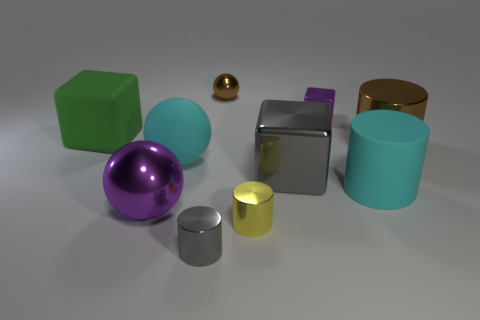There is a big brown shiny thing; how many big shiny objects are in front of it?
Your response must be concise. 2. How many balls are there?
Your answer should be compact. 3. Do the green matte block and the gray metallic cylinder have the same size?
Your response must be concise. No. There is a rubber object on the left side of the large metallic object that is in front of the large gray thing; is there a large shiny cylinder that is behind it?
Provide a short and direct response. No. There is a small object that is the same shape as the large green thing; what is it made of?
Your answer should be compact. Metal. There is a shiny cylinder behind the large rubber sphere; what color is it?
Your answer should be very brief. Brown. What is the size of the brown ball?
Make the answer very short. Small. There is a green matte cube; is its size the same as the gray thing that is on the right side of the small gray cylinder?
Make the answer very short. Yes. There is a metal ball in front of the shiny ball that is on the right side of the purple thing that is on the left side of the gray metallic cylinder; what color is it?
Your response must be concise. Purple. Do the gray object on the left side of the big gray object and the cyan cylinder have the same material?
Ensure brevity in your answer.  No. 